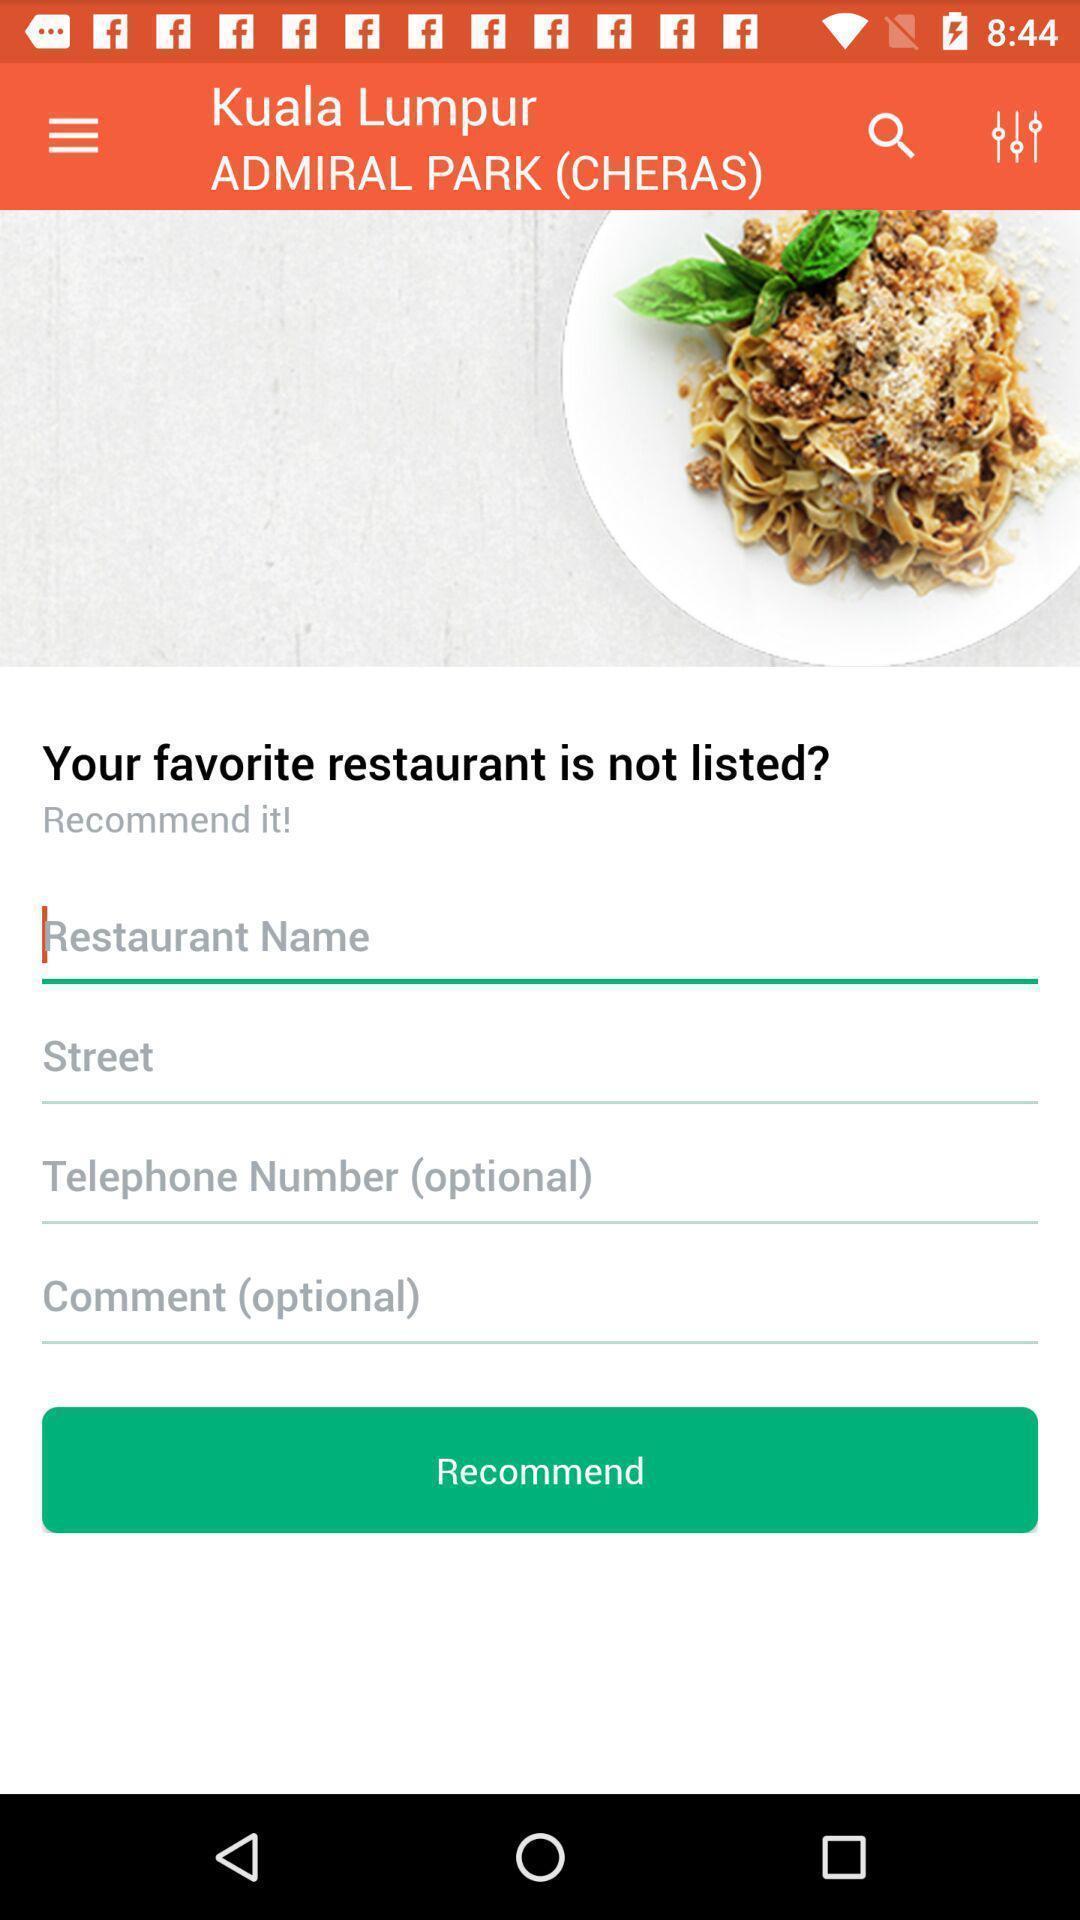Please provide a description for this image. Page to setup favorite restaurant details. 